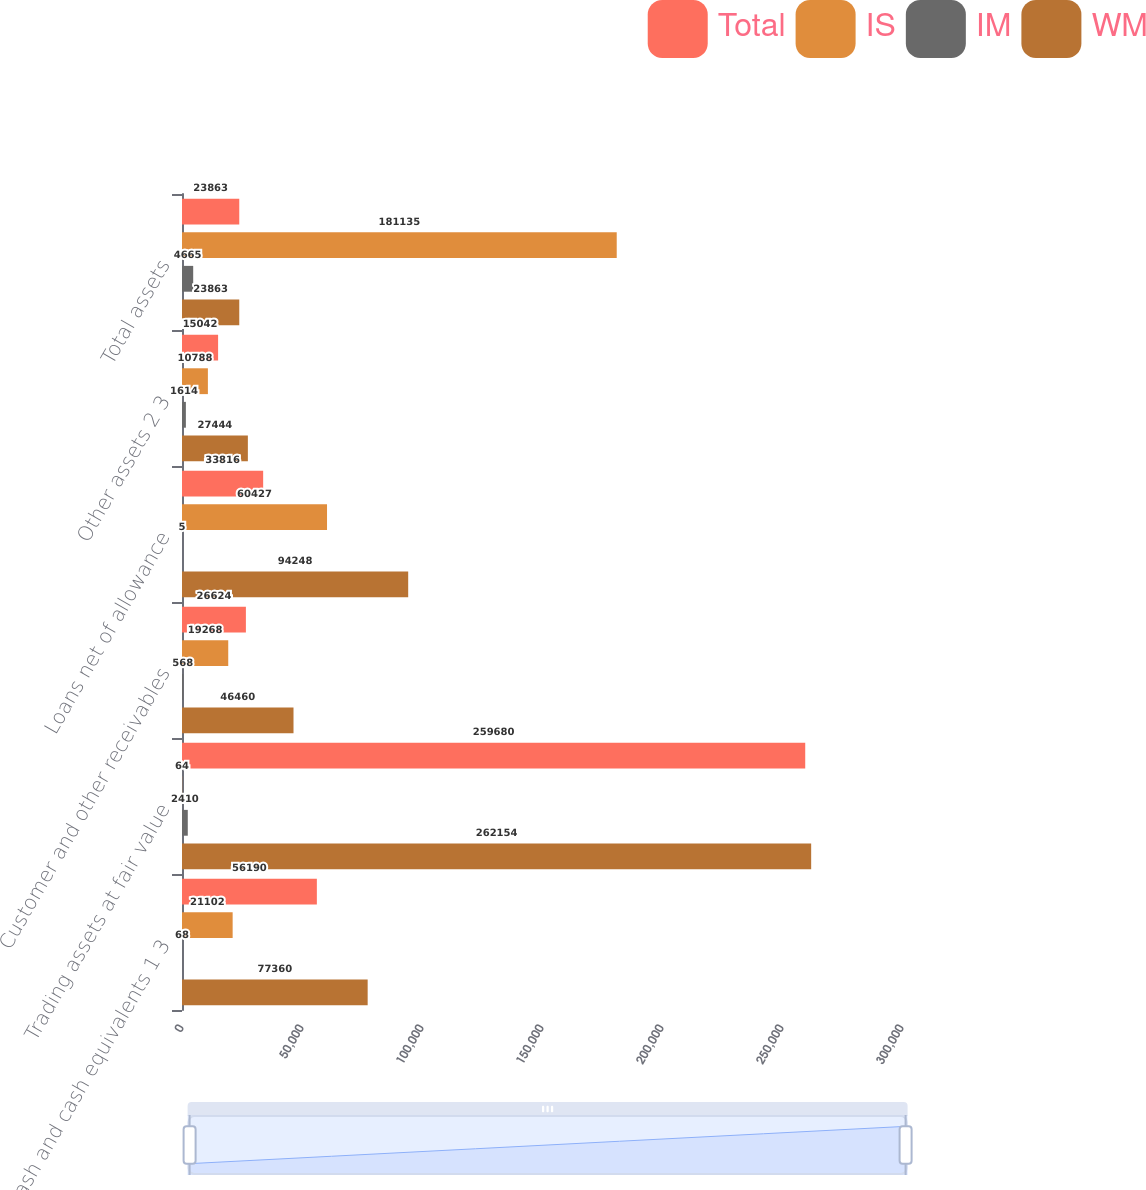<chart> <loc_0><loc_0><loc_500><loc_500><stacked_bar_chart><ecel><fcel>Cash and cash equivalents 1 3<fcel>Trading assets at fair value<fcel>Customer and other receivables<fcel>Loans net of allowance<fcel>Other assets 2 3<fcel>Total assets<nl><fcel>Total<fcel>56190<fcel>259680<fcel>26624<fcel>33816<fcel>15042<fcel>23863<nl><fcel>IS<fcel>21102<fcel>64<fcel>19268<fcel>60427<fcel>10788<fcel>181135<nl><fcel>IM<fcel>68<fcel>2410<fcel>568<fcel>5<fcel>1614<fcel>4665<nl><fcel>WM<fcel>77360<fcel>262154<fcel>46460<fcel>94248<fcel>27444<fcel>23863<nl></chart> 